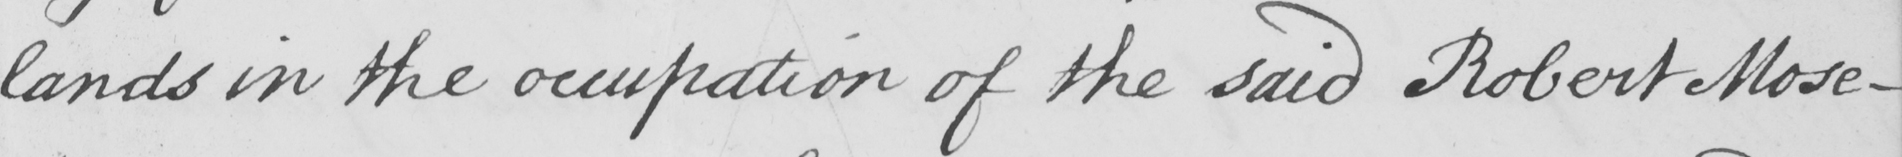What text is written in this handwritten line? lands in the occupation of the said Robert Mose- 